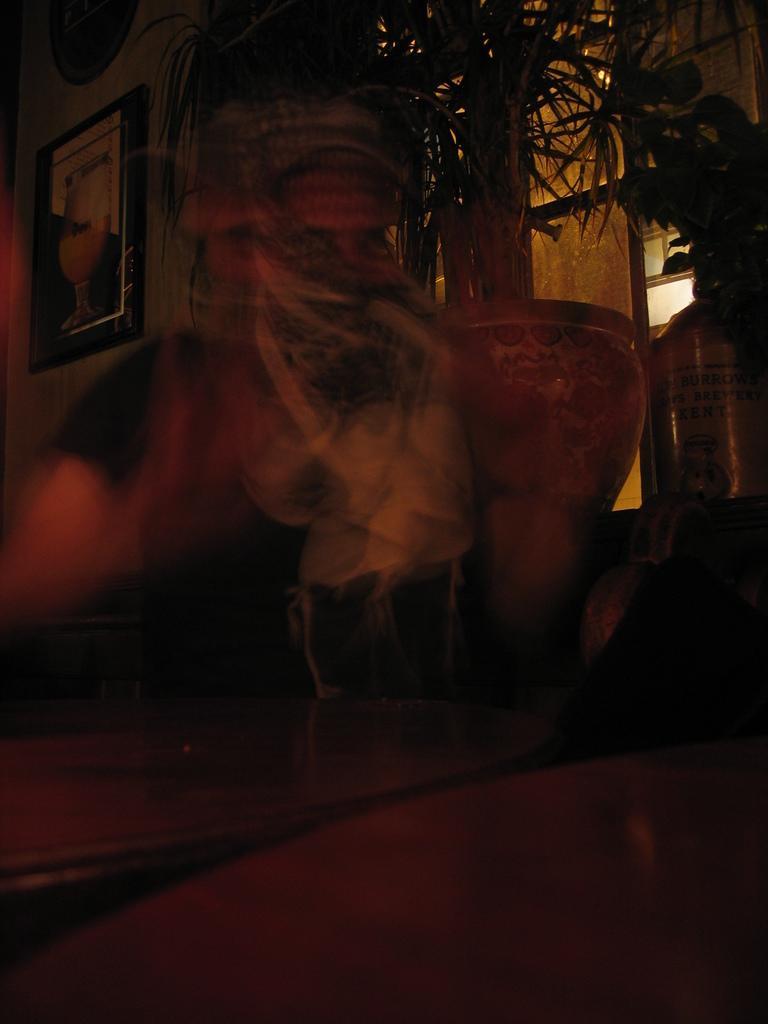How would you summarize this image in a sentence or two? This is a dark image, in this image I can see a person standing in the center of the image. In the top left corner, I can see a wall with wall painting. In the top right corner, I can see a potted plant. The background is blurred. 